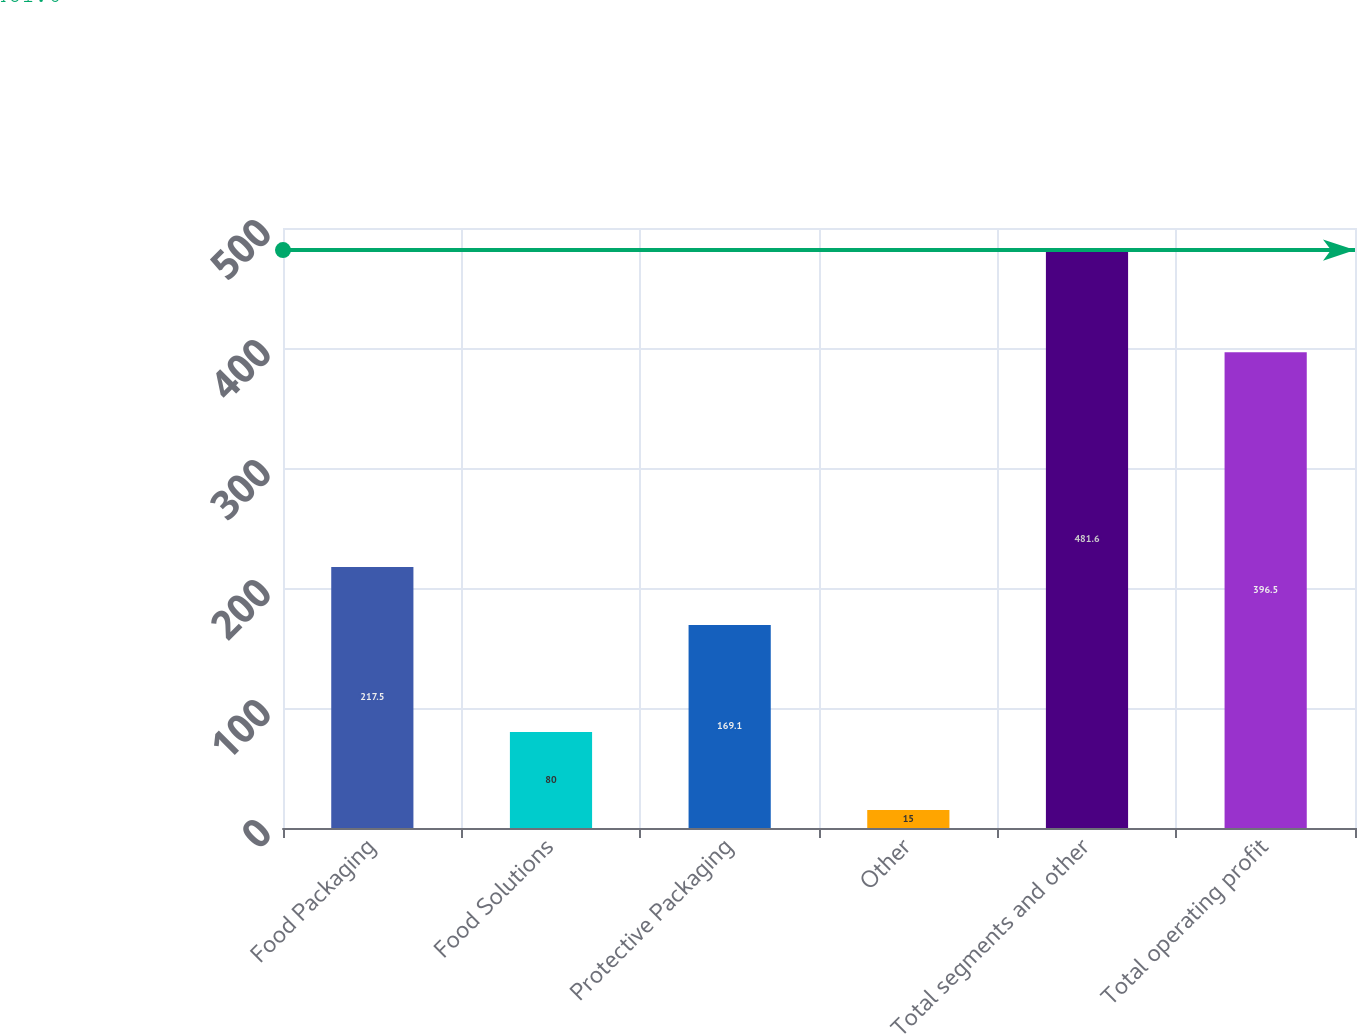Convert chart. <chart><loc_0><loc_0><loc_500><loc_500><bar_chart><fcel>Food Packaging<fcel>Food Solutions<fcel>Protective Packaging<fcel>Other<fcel>Total segments and other<fcel>Total operating profit<nl><fcel>217.5<fcel>80<fcel>169.1<fcel>15<fcel>481.6<fcel>396.5<nl></chart> 